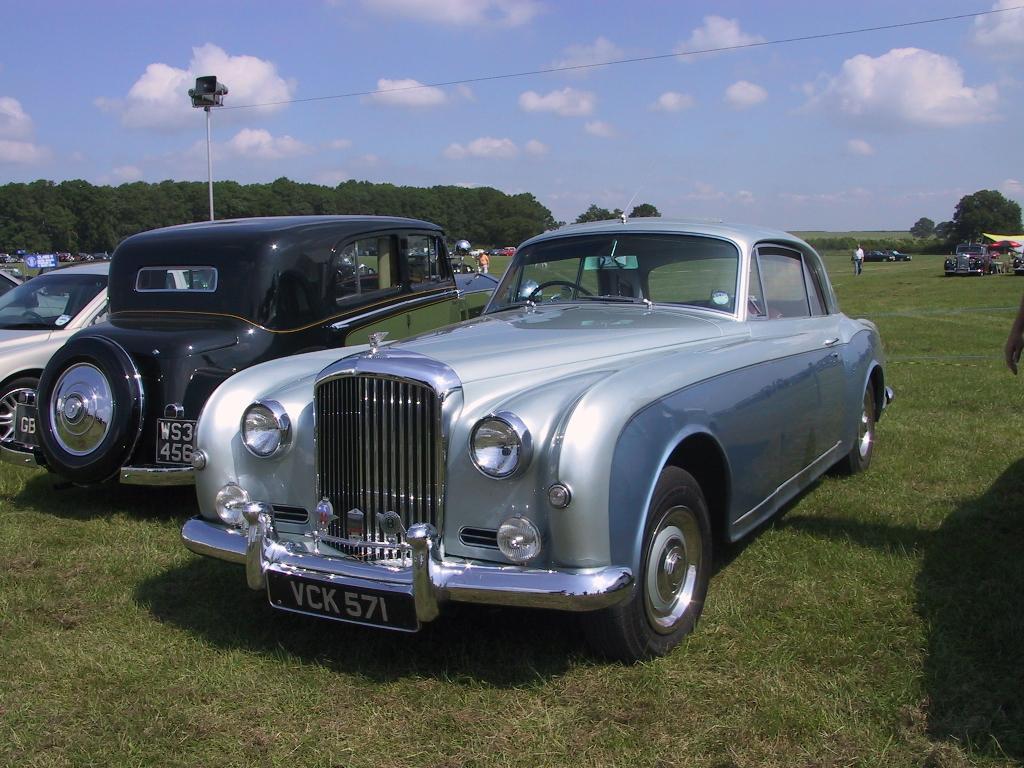How would you summarize this image in a sentence or two? In the foreground of the picture we can see cars, grass, pole, mic and person´s hand. On the right there are trees, cars, people, greenery, tent and other objects. Towards left there are trees, people and various objects. At the top we can see sky and cable. 